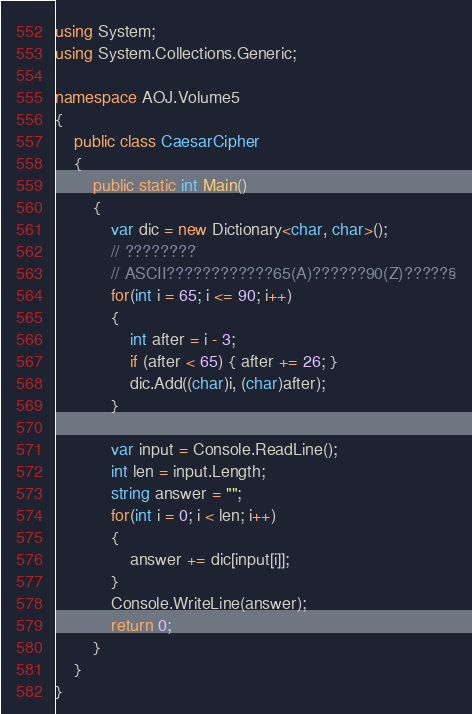Convert code to text. <code><loc_0><loc_0><loc_500><loc_500><_C#_>using System;
using System.Collections.Generic;

namespace AOJ.Volume5
{
    public class CaesarCipher
    {
        public static int Main()
        {
            var dic = new Dictionary<char, char>();
            // ????????¨
            // ASCII????????????65(A)??????90(Z)?????§
            for(int i = 65; i <= 90; i++)
            {
                int after = i - 3;
                if (after < 65) { after += 26; }
                dic.Add((char)i, (char)after);
            }

            var input = Console.ReadLine();
            int len = input.Length;
            string answer = "";
            for(int i = 0; i < len; i++)
            {
                answer += dic[input[i]];
            }
            Console.WriteLine(answer);
            return 0;
        }
    }
}</code> 